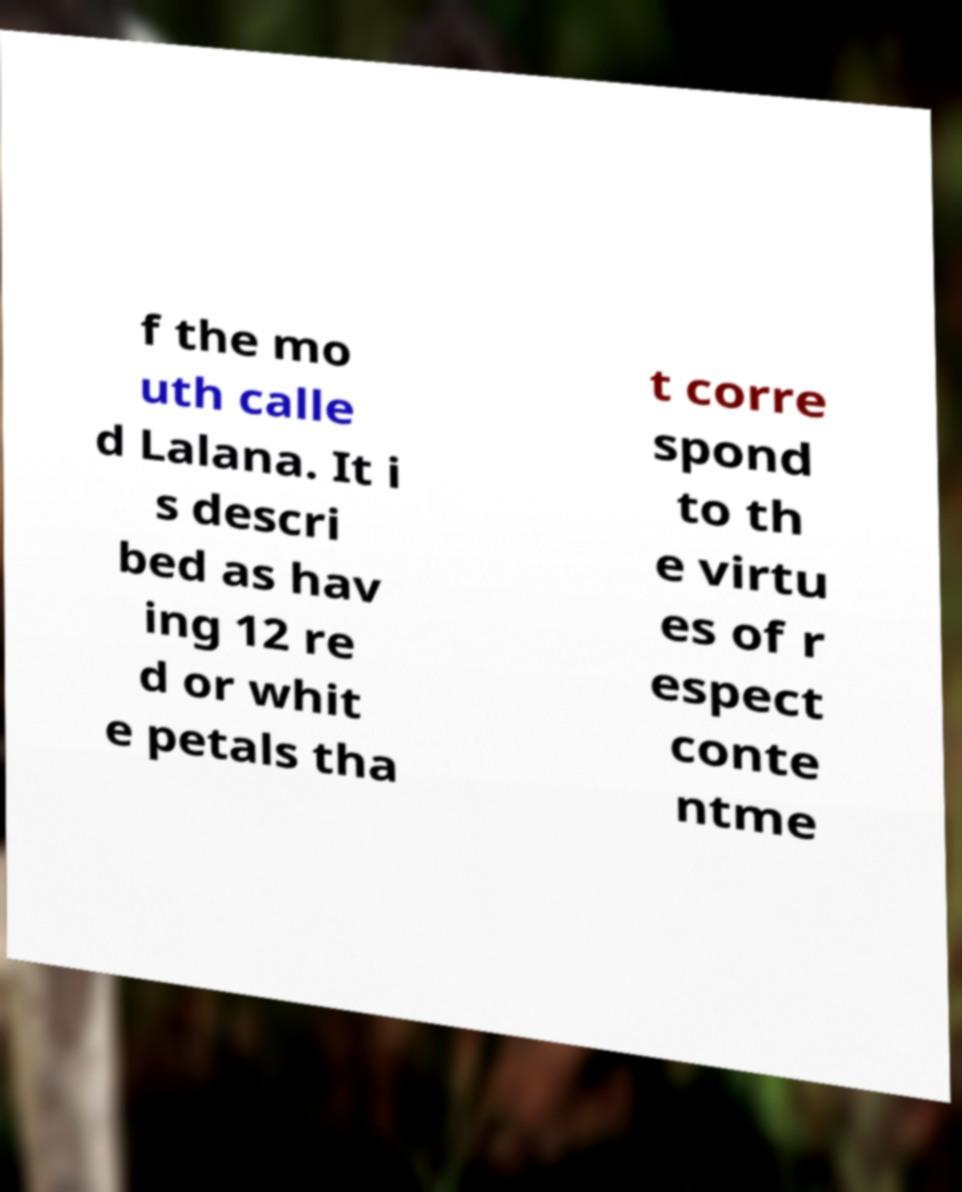For documentation purposes, I need the text within this image transcribed. Could you provide that? f the mo uth calle d Lalana. It i s descri bed as hav ing 12 re d or whit e petals tha t corre spond to th e virtu es of r espect conte ntme 